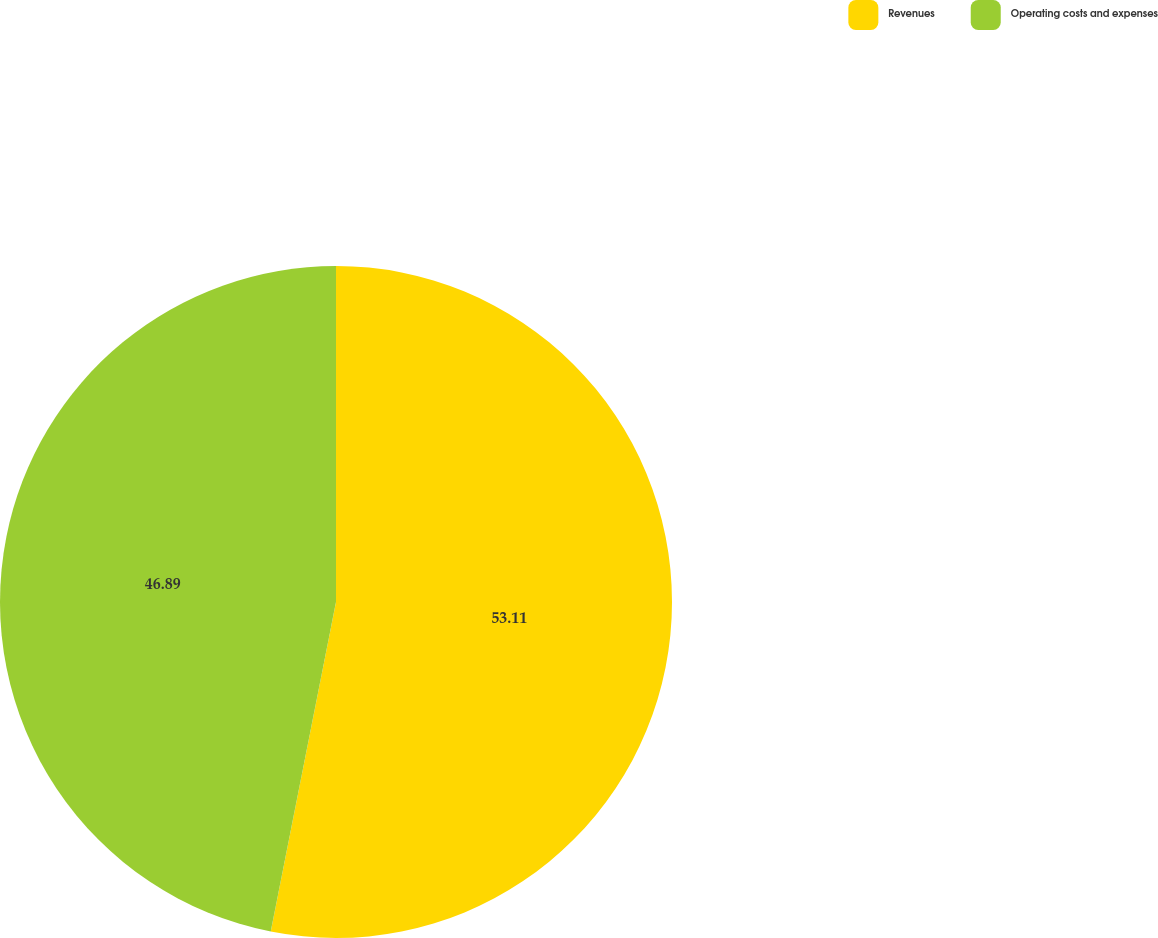Convert chart to OTSL. <chart><loc_0><loc_0><loc_500><loc_500><pie_chart><fcel>Revenues<fcel>Operating costs and expenses<nl><fcel>53.11%<fcel>46.89%<nl></chart> 